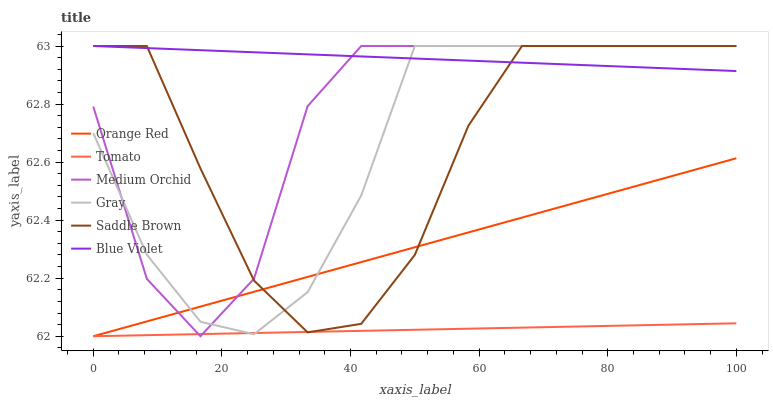Does Tomato have the minimum area under the curve?
Answer yes or no. Yes. Does Blue Violet have the maximum area under the curve?
Answer yes or no. Yes. Does Gray have the minimum area under the curve?
Answer yes or no. No. Does Gray have the maximum area under the curve?
Answer yes or no. No. Is Blue Violet the smoothest?
Answer yes or no. Yes. Is Medium Orchid the roughest?
Answer yes or no. Yes. Is Gray the smoothest?
Answer yes or no. No. Is Gray the roughest?
Answer yes or no. No. Does Tomato have the lowest value?
Answer yes or no. Yes. Does Gray have the lowest value?
Answer yes or no. No. Does Blue Violet have the highest value?
Answer yes or no. Yes. Does Orange Red have the highest value?
Answer yes or no. No. Is Orange Red less than Blue Violet?
Answer yes or no. Yes. Is Blue Violet greater than Orange Red?
Answer yes or no. Yes. Does Orange Red intersect Gray?
Answer yes or no. Yes. Is Orange Red less than Gray?
Answer yes or no. No. Is Orange Red greater than Gray?
Answer yes or no. No. Does Orange Red intersect Blue Violet?
Answer yes or no. No. 